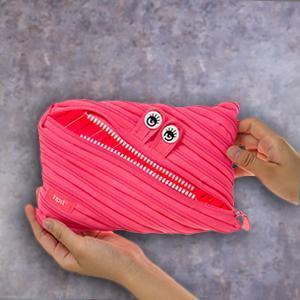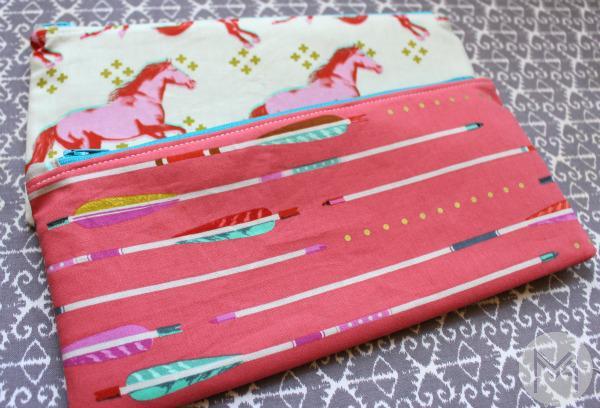The first image is the image on the left, the second image is the image on the right. Examine the images to the left and right. Is the description "There is a single pink bag in the image on the left." accurate? Answer yes or no. Yes. 